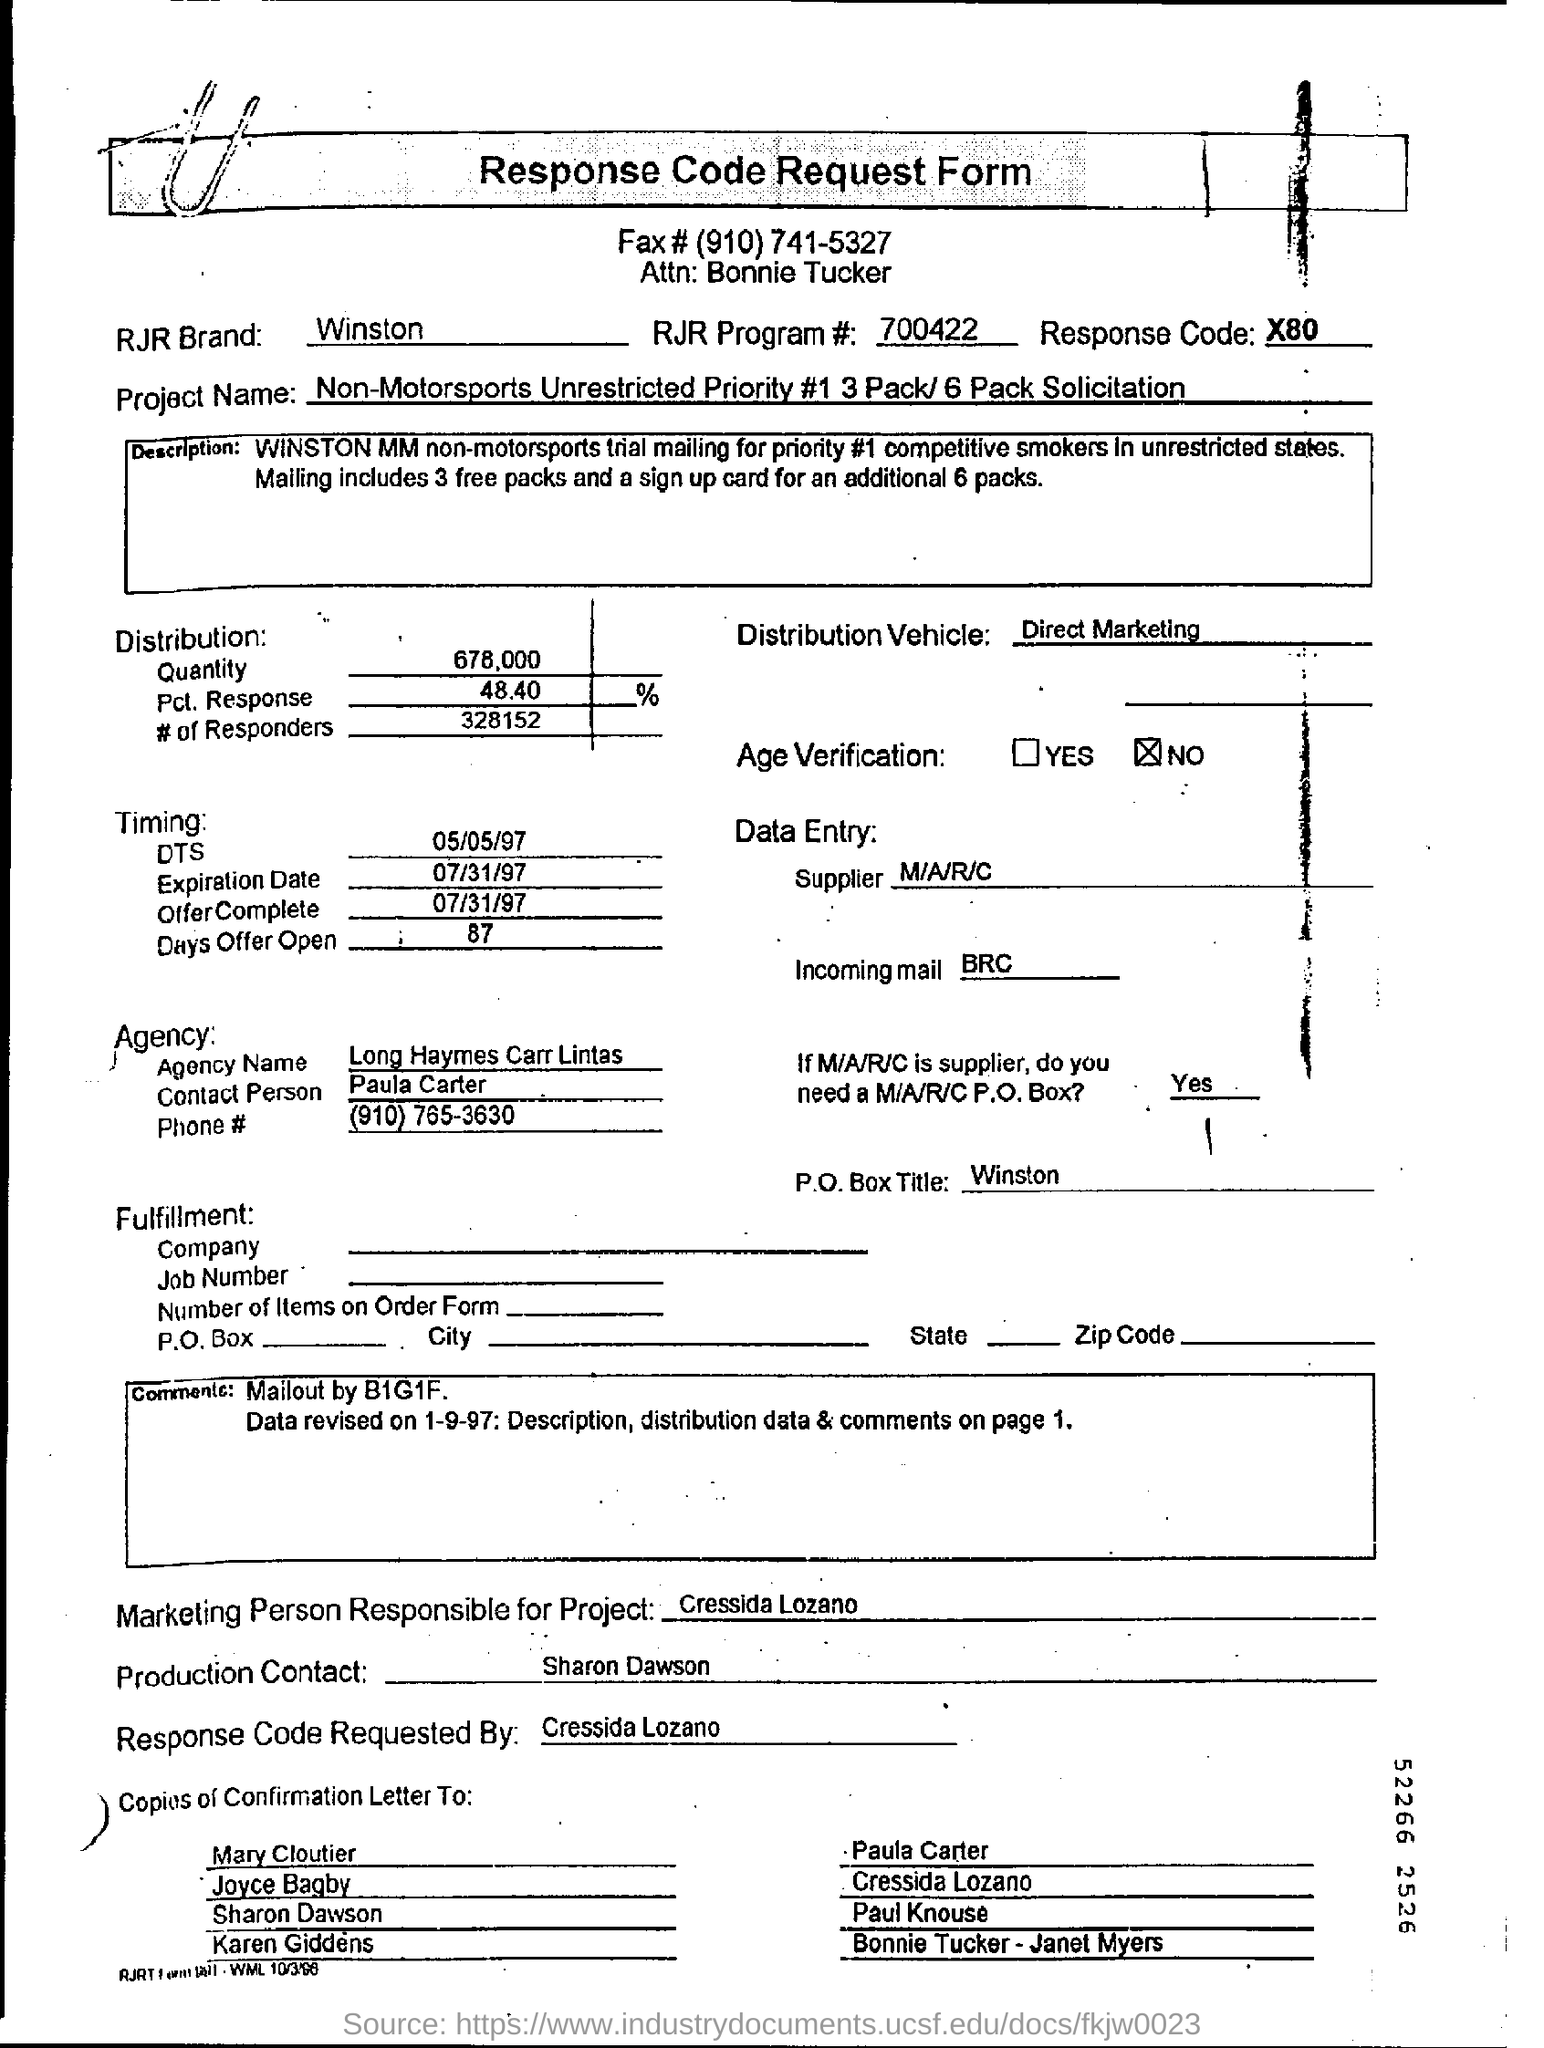Draw attention to some important aspects in this diagram. This solicitation is for a non-motorsports project with unrestricted priority, with a focus on a 3 pack or 6 pack solution. According to the project, 3 free packs of cigarettes will be provided. The contact person at the agency is named Paula Carter. The RJR brand is associated with the Winston brand of cigarettes. The marketing person responsible for Project is Cressida Lozano. 